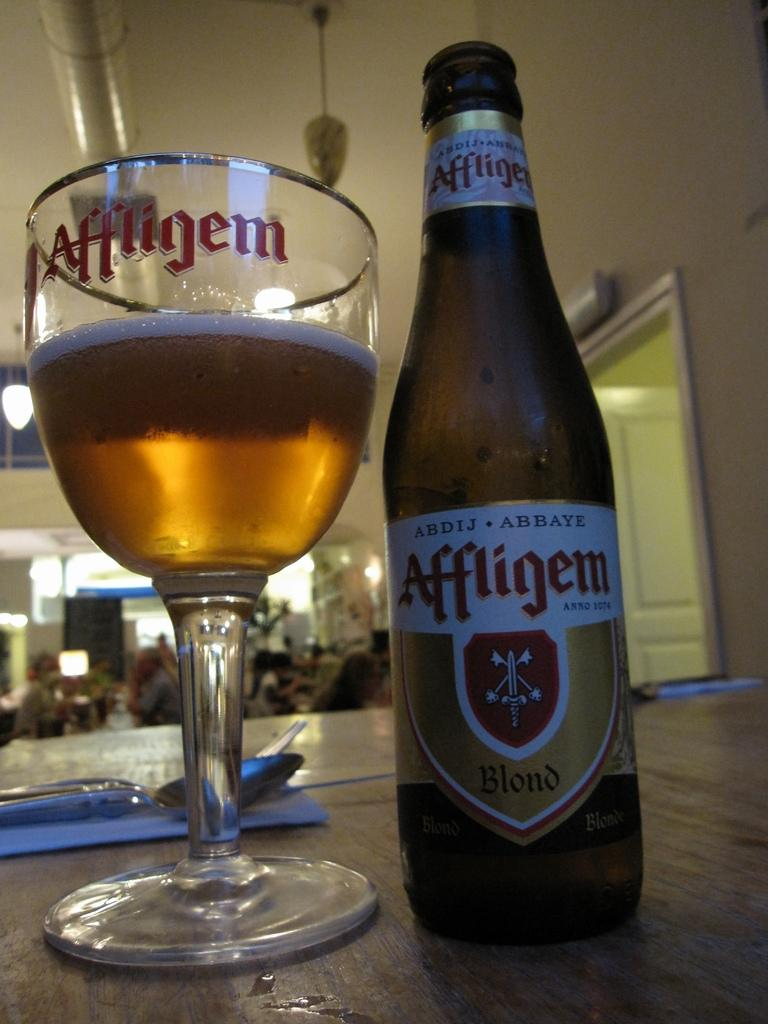<image>
Share a concise interpretation of the image provided. A bottle of Affligen Blond beer has been poured into a beer glass 